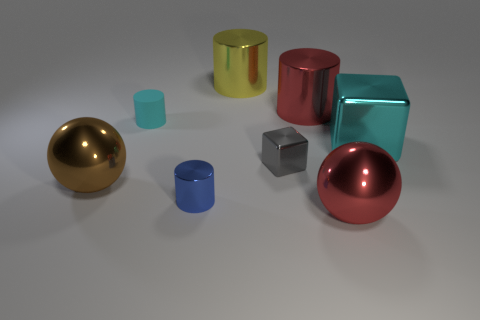Subtract all tiny blue metallic cylinders. How many cylinders are left? 3 Add 1 brown things. How many objects exist? 9 Subtract all blue cylinders. How many cylinders are left? 3 Subtract all blocks. How many objects are left? 6 Add 6 large cyan things. How many large cyan things are left? 7 Add 3 cubes. How many cubes exist? 5 Subtract 1 cyan cubes. How many objects are left? 7 Subtract 1 spheres. How many spheres are left? 1 Subtract all gray balls. Subtract all blue cubes. How many balls are left? 2 Subtract all large gray balls. Subtract all blocks. How many objects are left? 6 